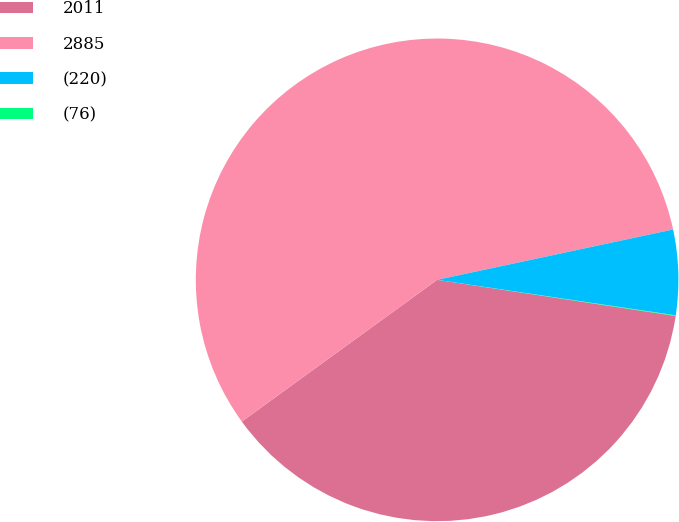Convert chart. <chart><loc_0><loc_0><loc_500><loc_500><pie_chart><fcel>2011<fcel>2885<fcel>(220)<fcel>(76)<nl><fcel>37.62%<fcel>56.65%<fcel>5.7%<fcel>0.04%<nl></chart> 